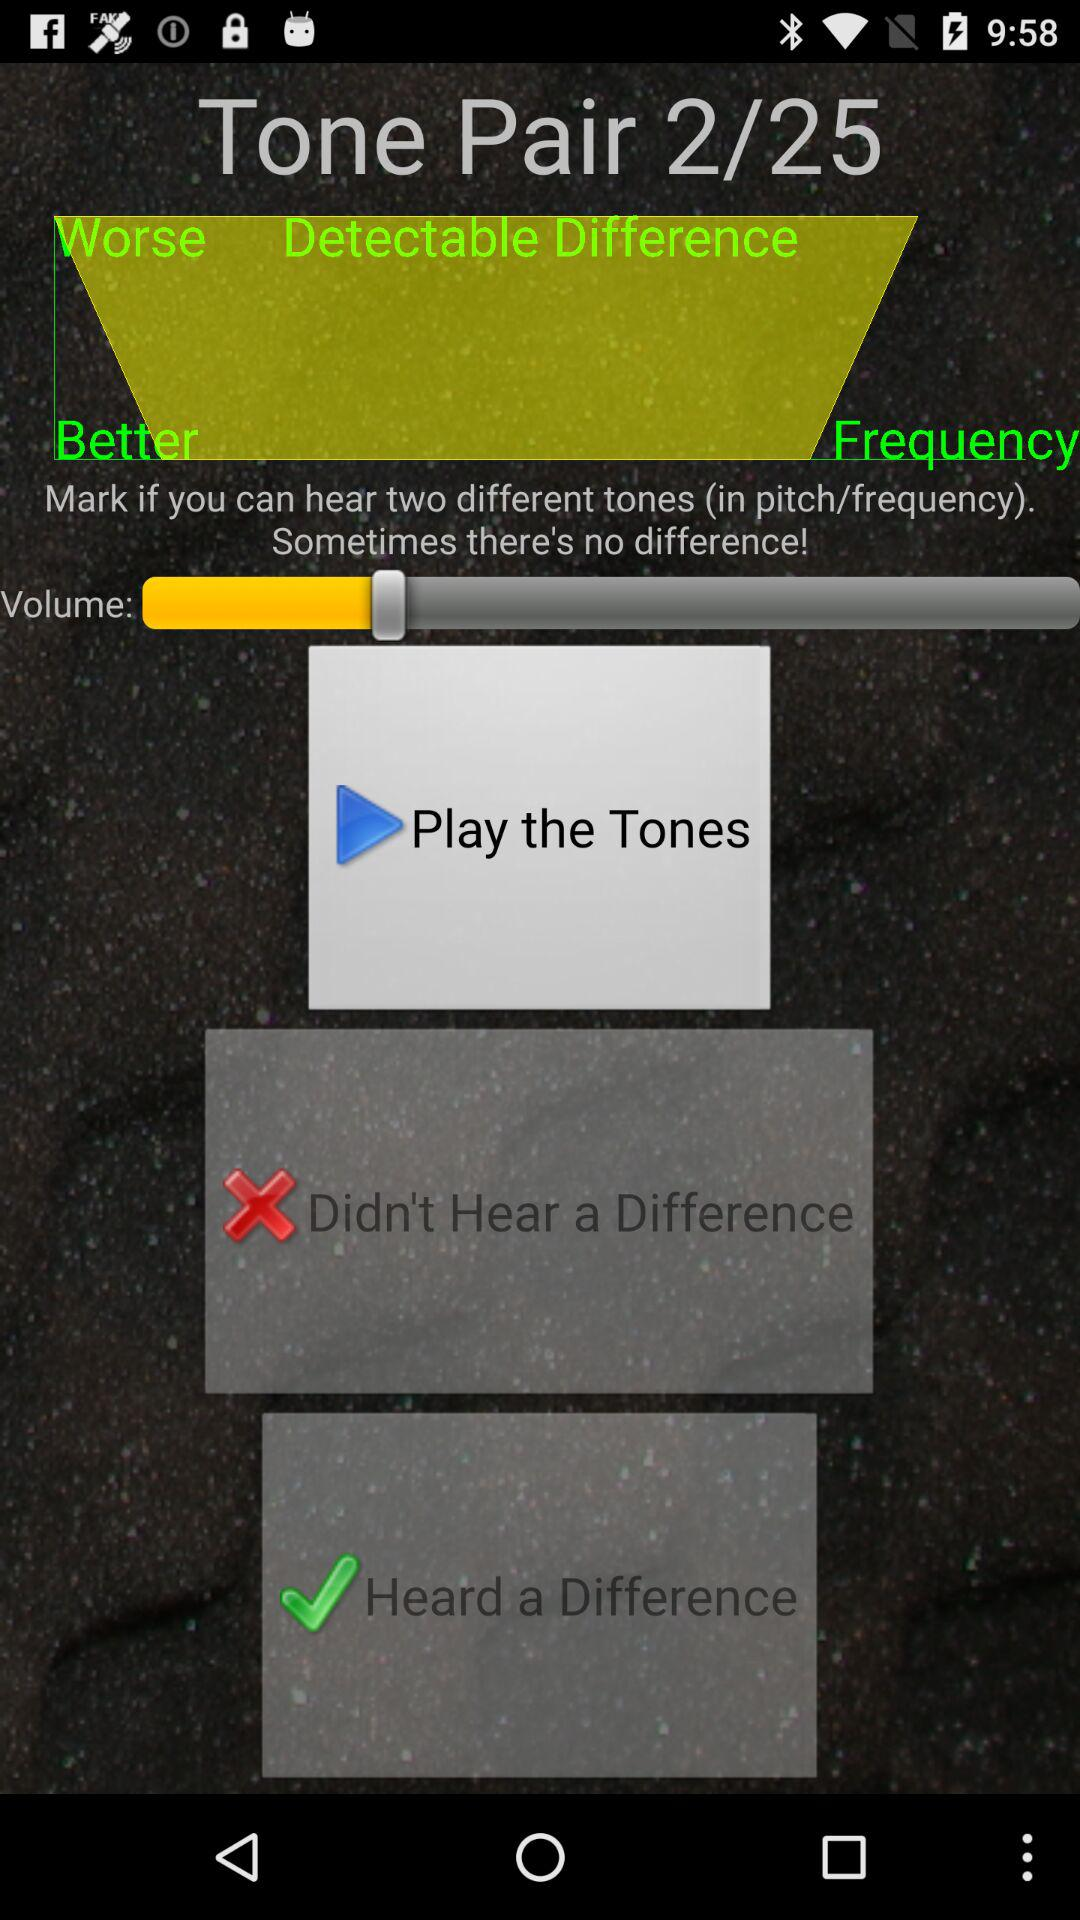At which tone pair are we right now? Right now, you are at tone pair 2. 